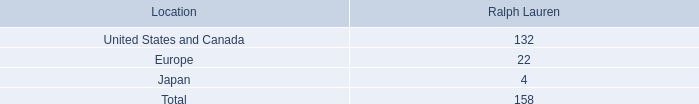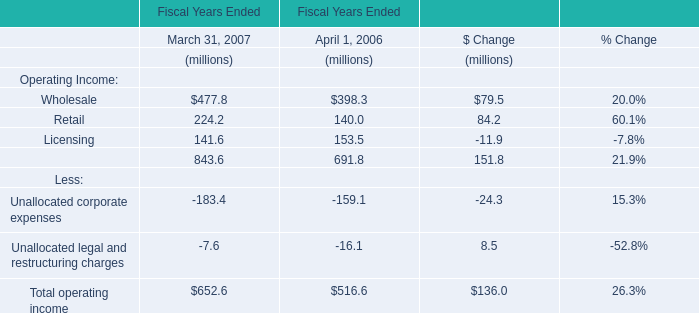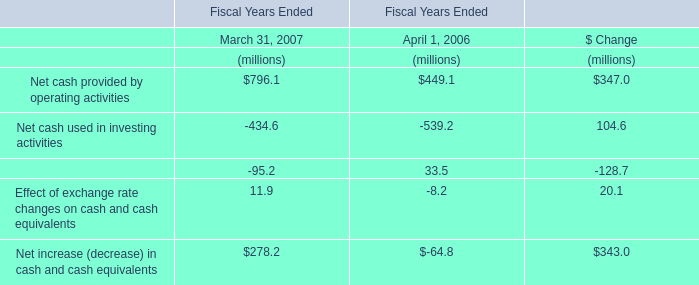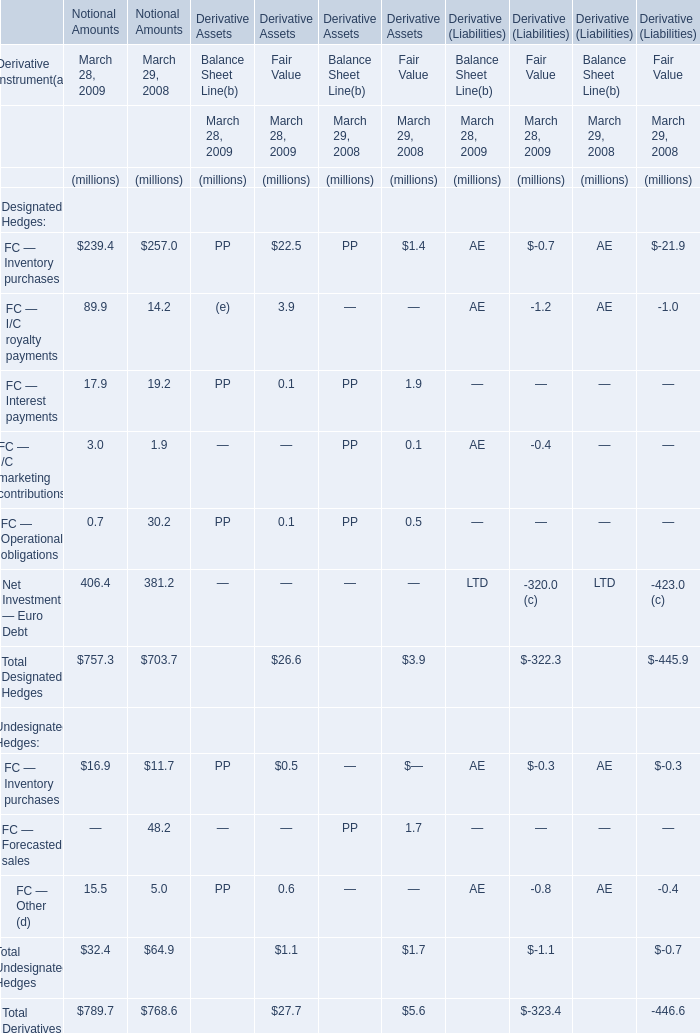What's the current increasing rate of Net Investment — Euro Debt for Notional Amounts ? 
Computations: ((406.4 - 381.2) / 381.2)
Answer: 0.06611. 